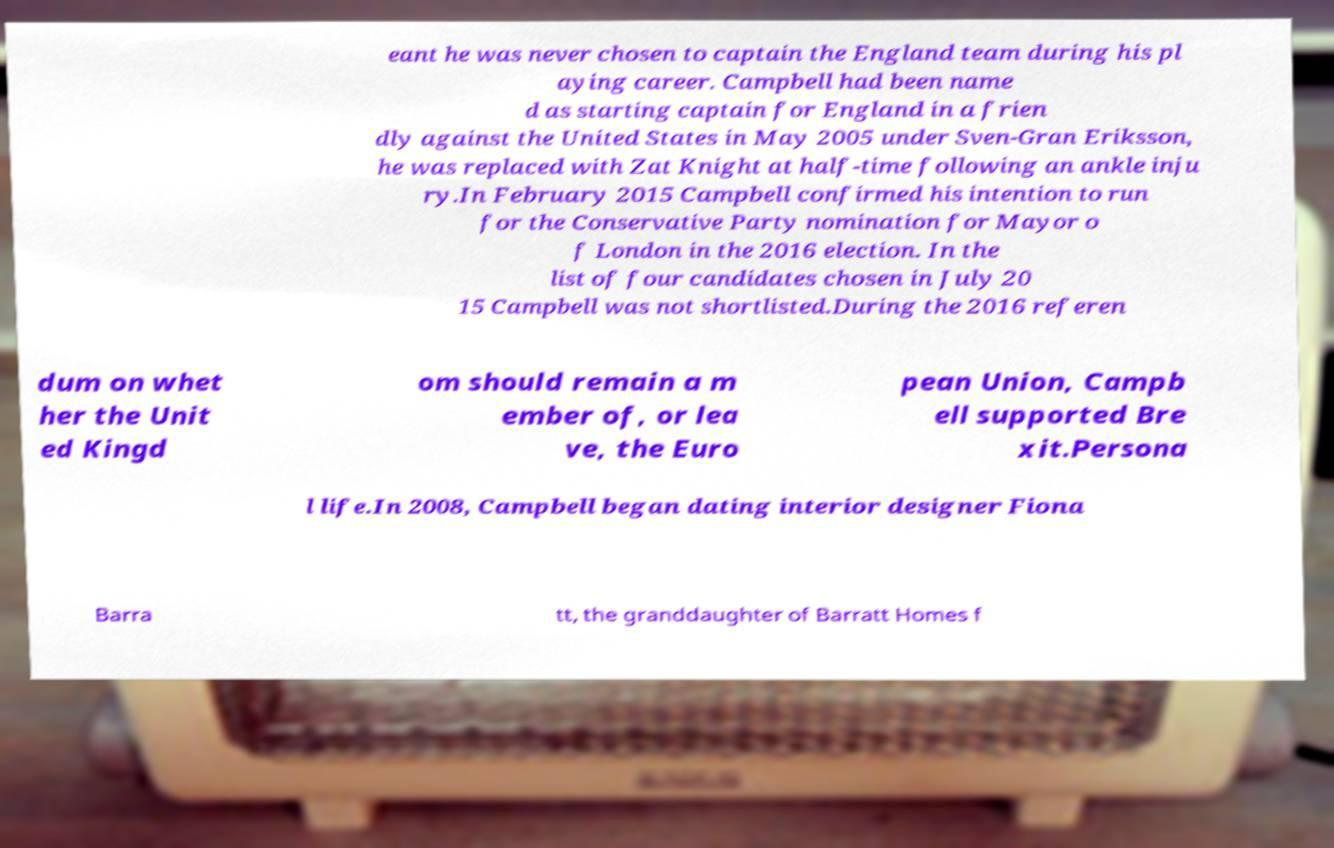What messages or text are displayed in this image? I need them in a readable, typed format. eant he was never chosen to captain the England team during his pl aying career. Campbell had been name d as starting captain for England in a frien dly against the United States in May 2005 under Sven-Gran Eriksson, he was replaced with Zat Knight at half-time following an ankle inju ry.In February 2015 Campbell confirmed his intention to run for the Conservative Party nomination for Mayor o f London in the 2016 election. In the list of four candidates chosen in July 20 15 Campbell was not shortlisted.During the 2016 referen dum on whet her the Unit ed Kingd om should remain a m ember of, or lea ve, the Euro pean Union, Campb ell supported Bre xit.Persona l life.In 2008, Campbell began dating interior designer Fiona Barra tt, the granddaughter of Barratt Homes f 